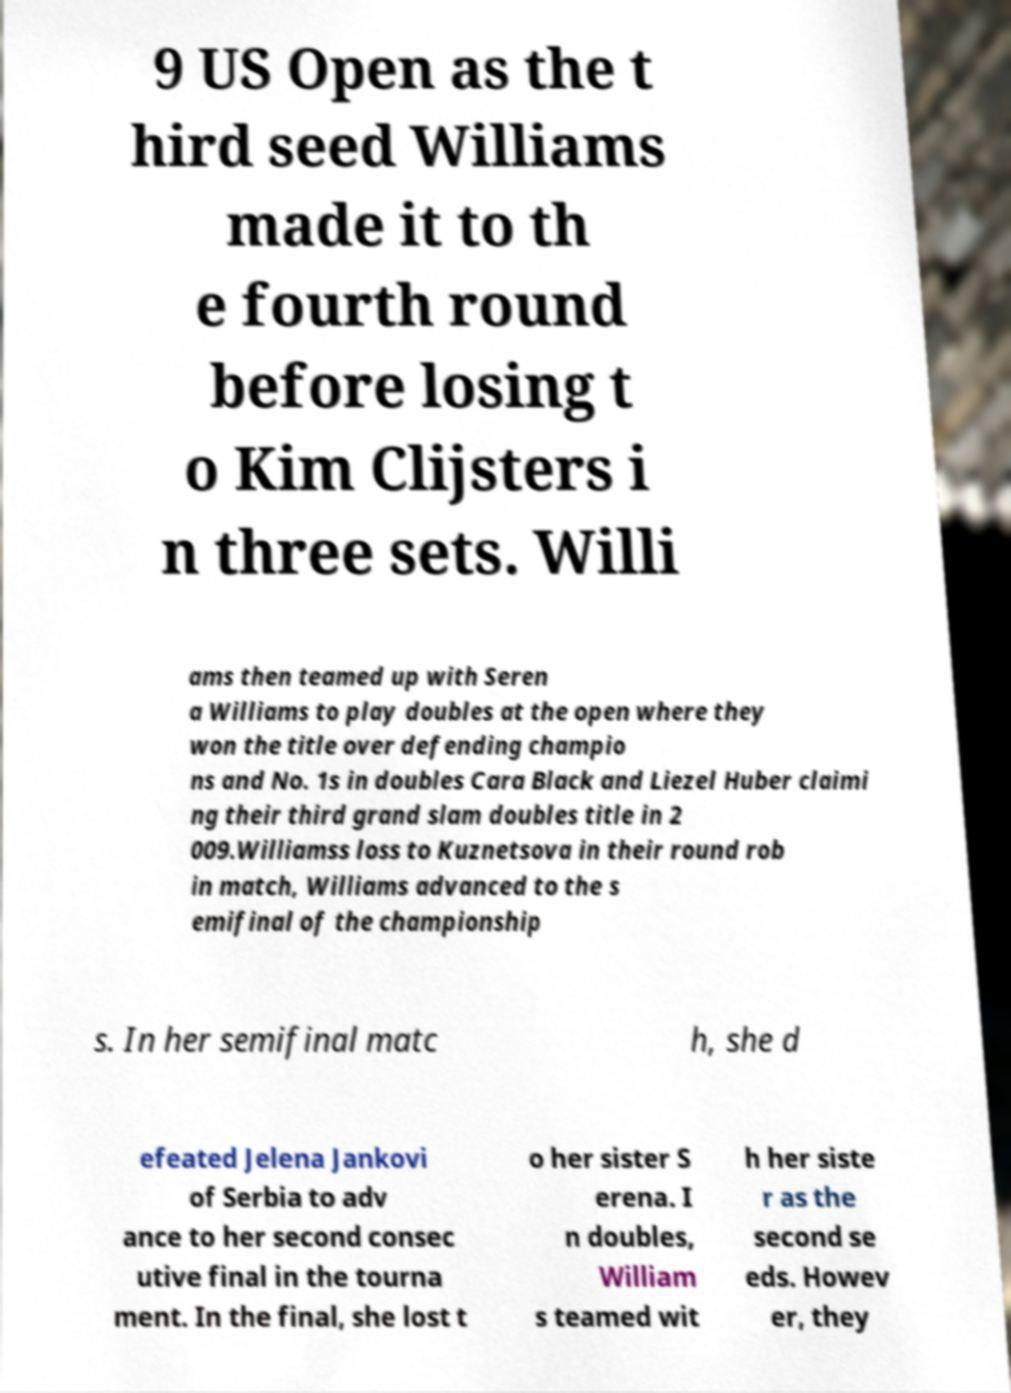What messages or text are displayed in this image? I need them in a readable, typed format. 9 US Open as the t hird seed Williams made it to th e fourth round before losing t o Kim Clijsters i n three sets. Willi ams then teamed up with Seren a Williams to play doubles at the open where they won the title over defending champio ns and No. 1s in doubles Cara Black and Liezel Huber claimi ng their third grand slam doubles title in 2 009.Williamss loss to Kuznetsova in their round rob in match, Williams advanced to the s emifinal of the championship s. In her semifinal matc h, she d efeated Jelena Jankovi of Serbia to adv ance to her second consec utive final in the tourna ment. In the final, she lost t o her sister S erena. I n doubles, William s teamed wit h her siste r as the second se eds. Howev er, they 